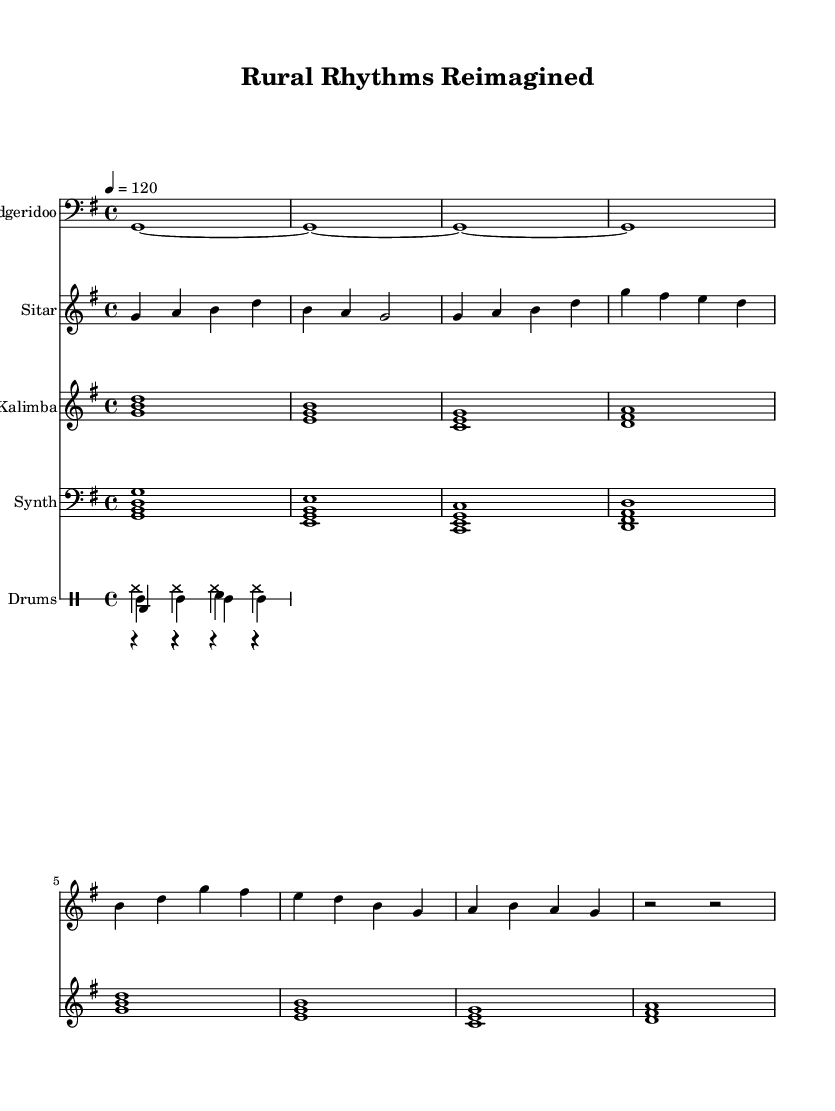What is the key signature of this music? The key signature is G major, which has one sharp (F#). This can be determined by looking for the sharp sign at the beginning of the staff and recognizing that it indicates the key of G major.
Answer: G major What is the time signature of this music? The time signature is 4/4, which is indicated at the beginning of the staff. This means there are four beats per measure and the quarter note gets one beat.
Answer: 4/4 What is the tempo marking of this piece? The tempo marking of the piece indicates a speed of quarter note equals 120 beats per minute, which is noted at the beginning of the score. This tells us how fast to play the piece.
Answer: 120 How many different instruments are featured in this composition? There are four different instruments featured: didgeridoo, sitar, kalimba, and synth. Each instrument is indicated in its own staff at the beginning of the score.
Answer: Four Which indigenous instrument is used in this composition? The didgeridoo is the indigenous instrument used in this composition, as it is specified on its staff and is characteristic of Australian Aboriginal music.
Answer: Didgeridoo What type of percussion is predominantly used in the drum part? The predominant type of percussion used in the drum part is a bass drum, as seen in the first drum line where the bass drum is played regularly.
Answer: Bass drum What genre does this music represent? This music represents contemporary fusion, blending indigenous sounds with modern electronic beats, as evidenced by the combination of traditional instruments and synthesized sounds.
Answer: Contemporary fusion 